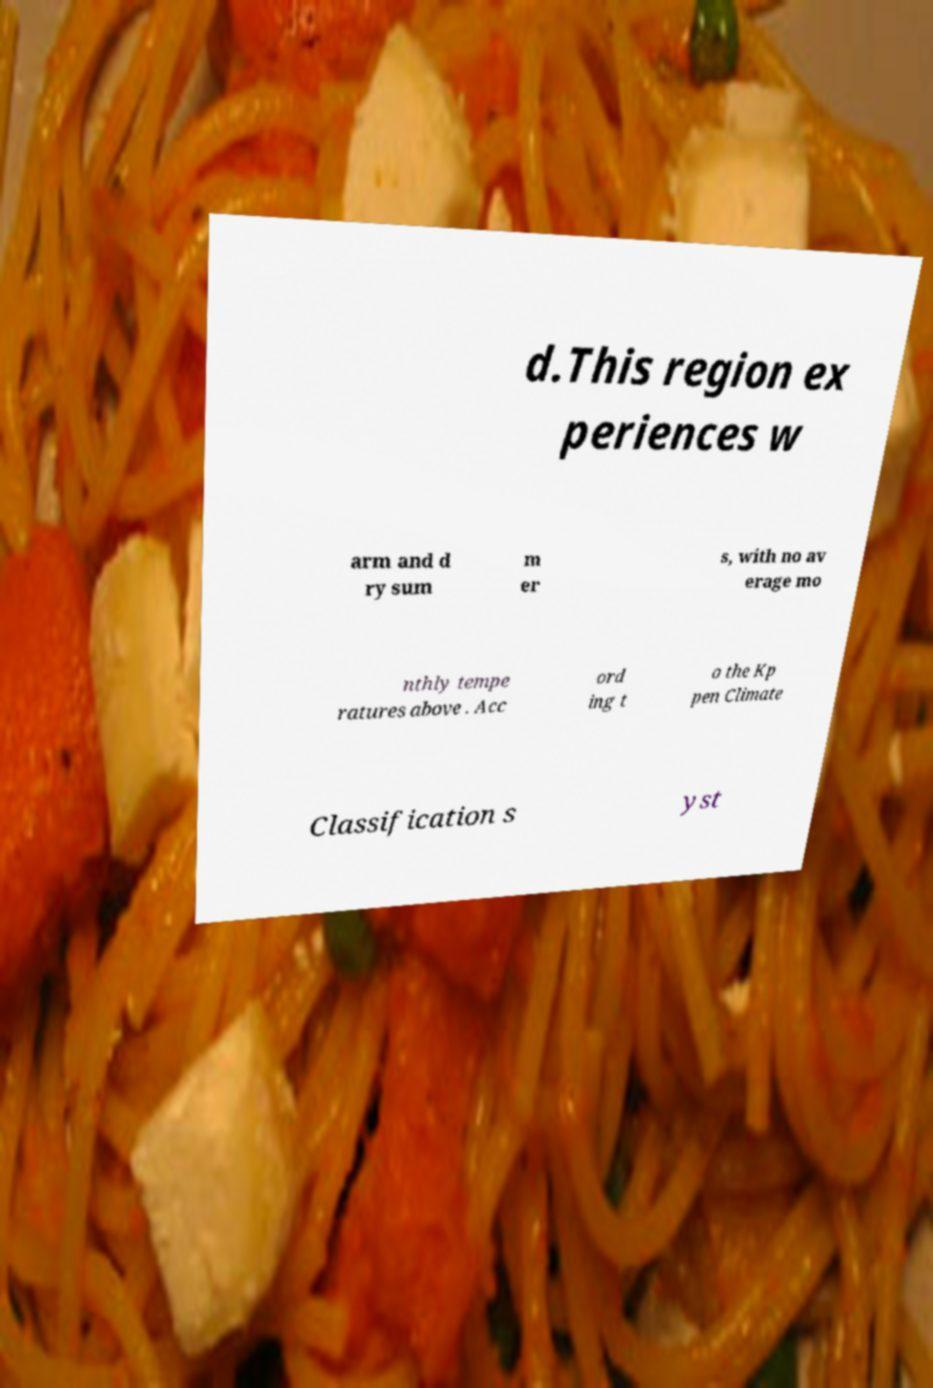I need the written content from this picture converted into text. Can you do that? d.This region ex periences w arm and d ry sum m er s, with no av erage mo nthly tempe ratures above . Acc ord ing t o the Kp pen Climate Classification s yst 